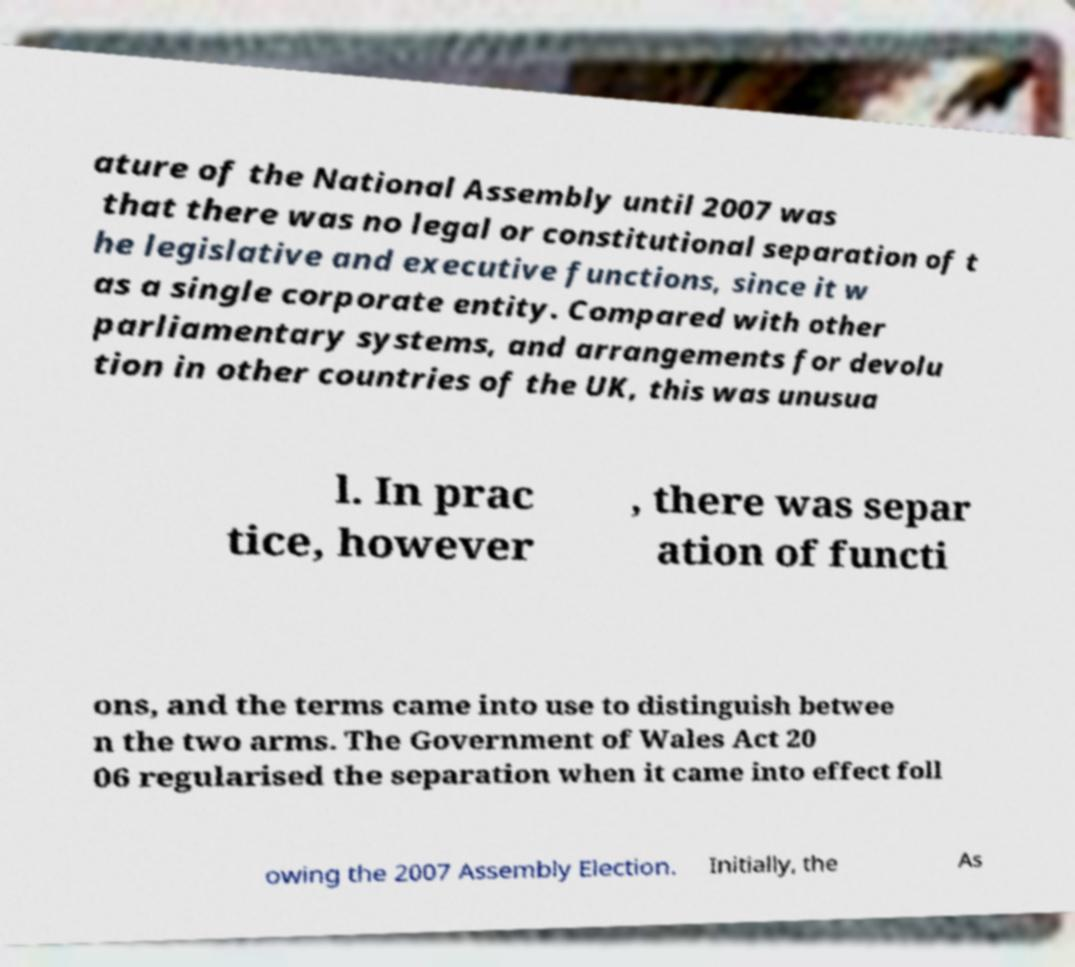Please read and relay the text visible in this image. What does it say? ature of the National Assembly until 2007 was that there was no legal or constitutional separation of t he legislative and executive functions, since it w as a single corporate entity. Compared with other parliamentary systems, and arrangements for devolu tion in other countries of the UK, this was unusua l. In prac tice, however , there was separ ation of functi ons, and the terms came into use to distinguish betwee n the two arms. The Government of Wales Act 20 06 regularised the separation when it came into effect foll owing the 2007 Assembly Election. Initially, the As 